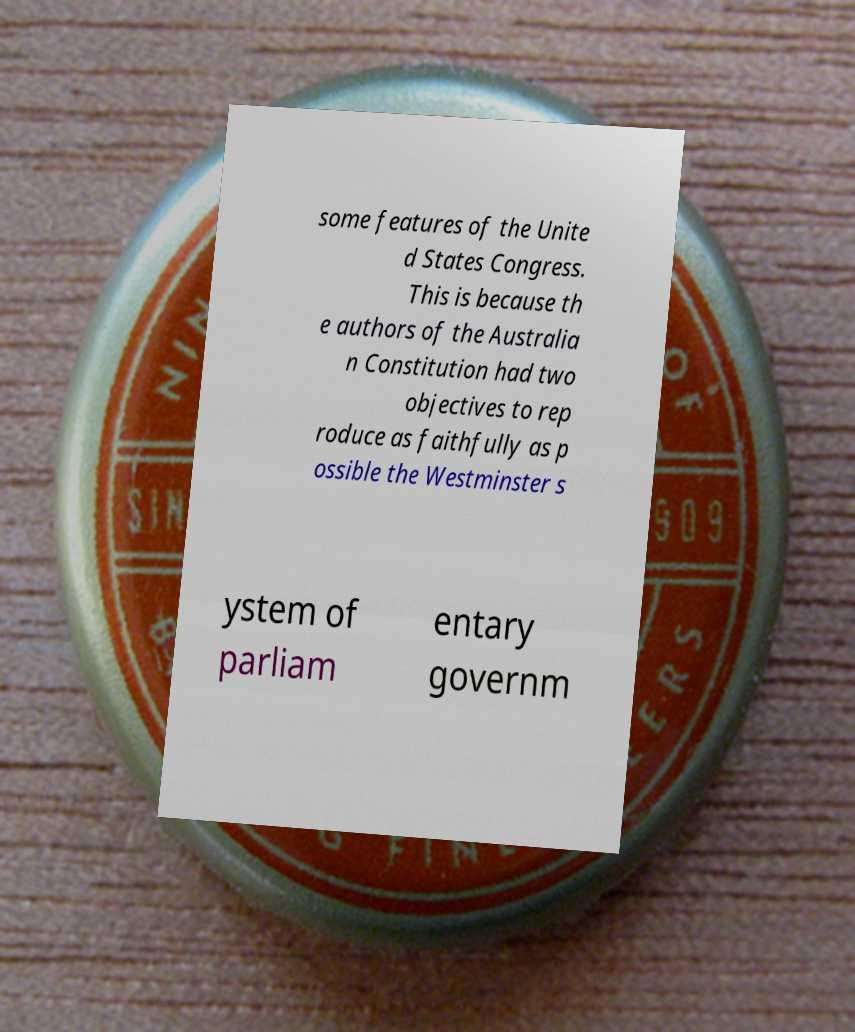I need the written content from this picture converted into text. Can you do that? some features of the Unite d States Congress. This is because th e authors of the Australia n Constitution had two objectives to rep roduce as faithfully as p ossible the Westminster s ystem of parliam entary governm 